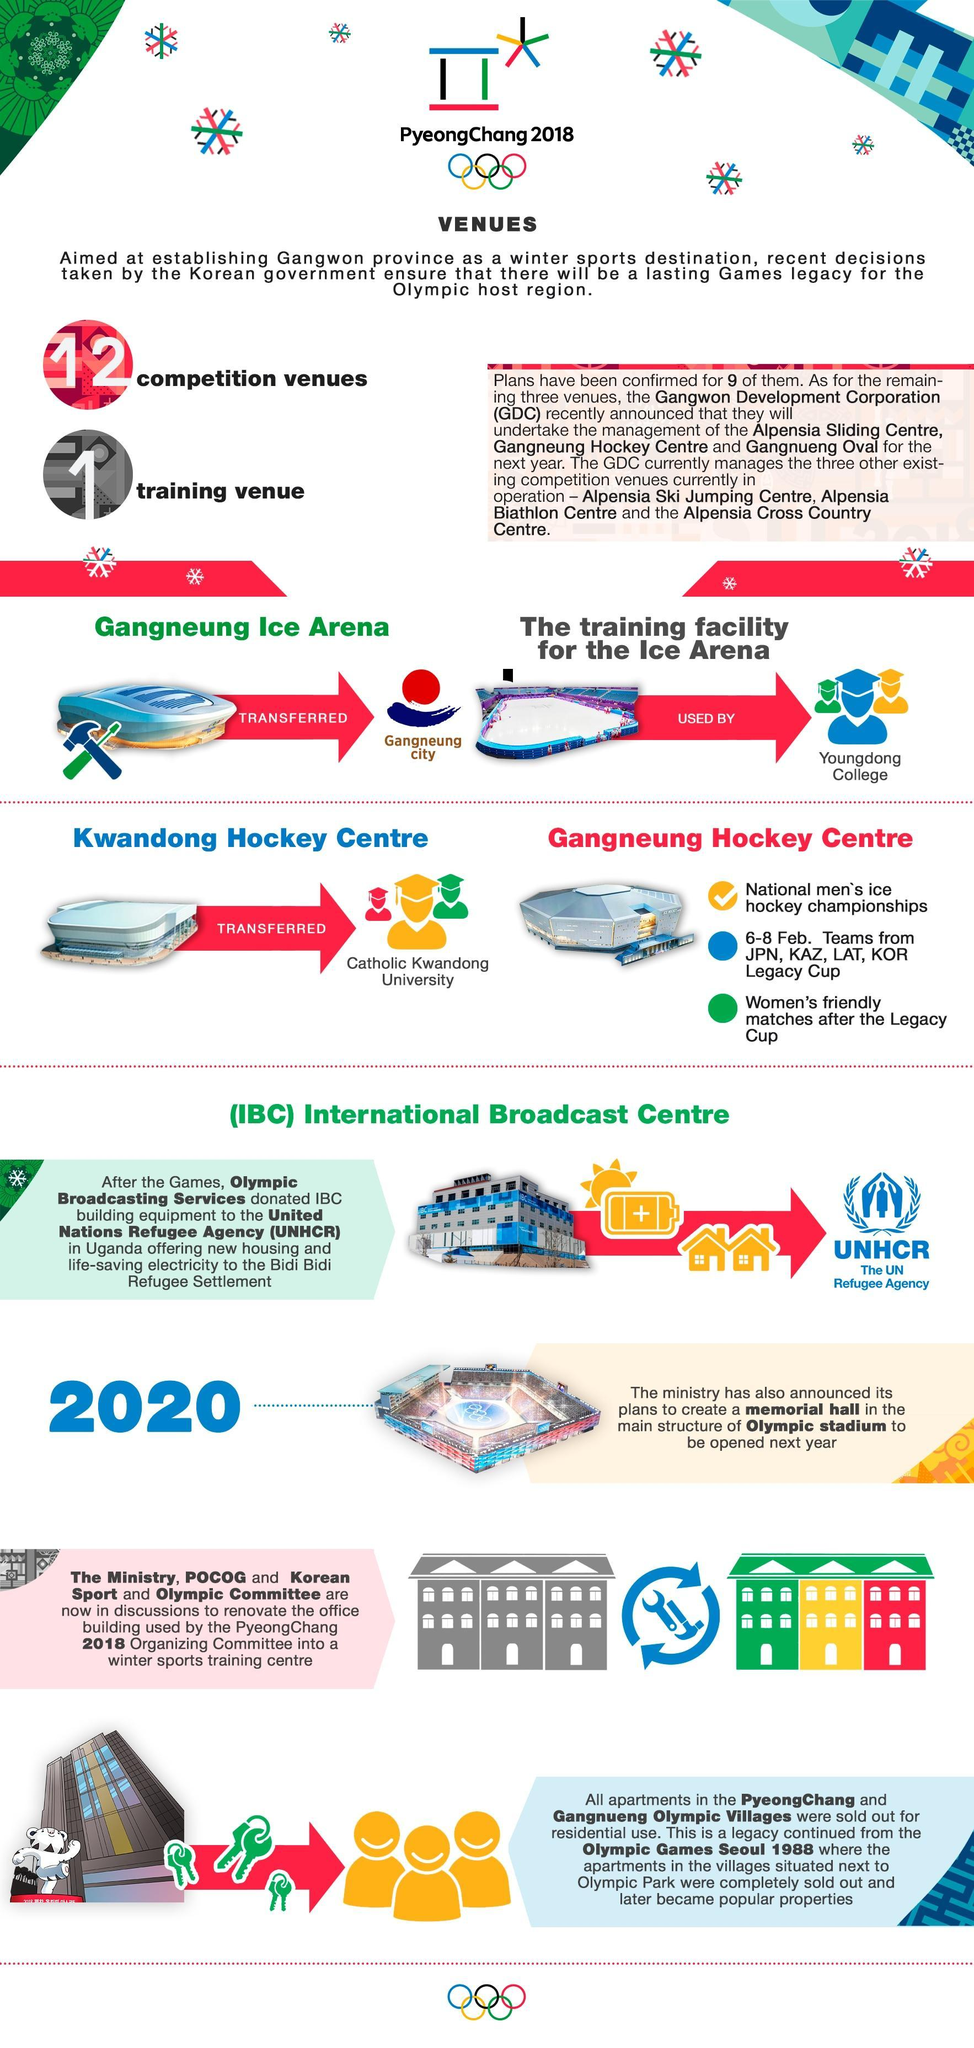Who will be using the training facility attached to the Ice Arena?
Answer the question with a short phrase. Youngdong College How many teams played in the Legacy Cup hockey tournament? 4 Which hockey event was held from 6-8 of February at Gangneung Hockey Centre? Legacy Cup At which 2018 Winter Olympics venue was the Legacy cup held? Gangneung Hockey Centre Building equipment from IBC were donated to aid the people in which location? Bidi Bidi Refugee Settlement Which 2018 Winter Olympic venue has been transferred to Gangneung City? Gangneung Ice Arena Which was the venue for Women's friendly matches held after the Legacy Cup? Gangneung Hockey Centre Who is using the Kwandong Hockey centre after the winter Olympics of 2018? Catholic Kwandong University 